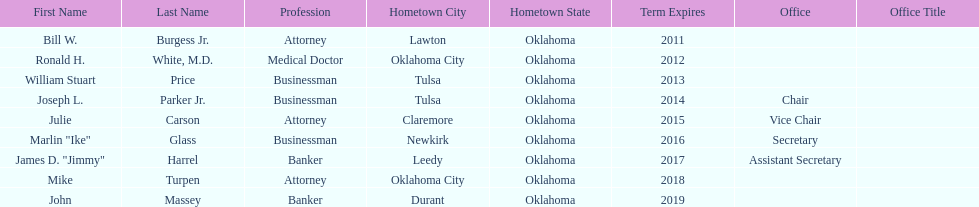Other members of the state regents from tulsa besides joseph l. parker jr. William Stuart Price. 